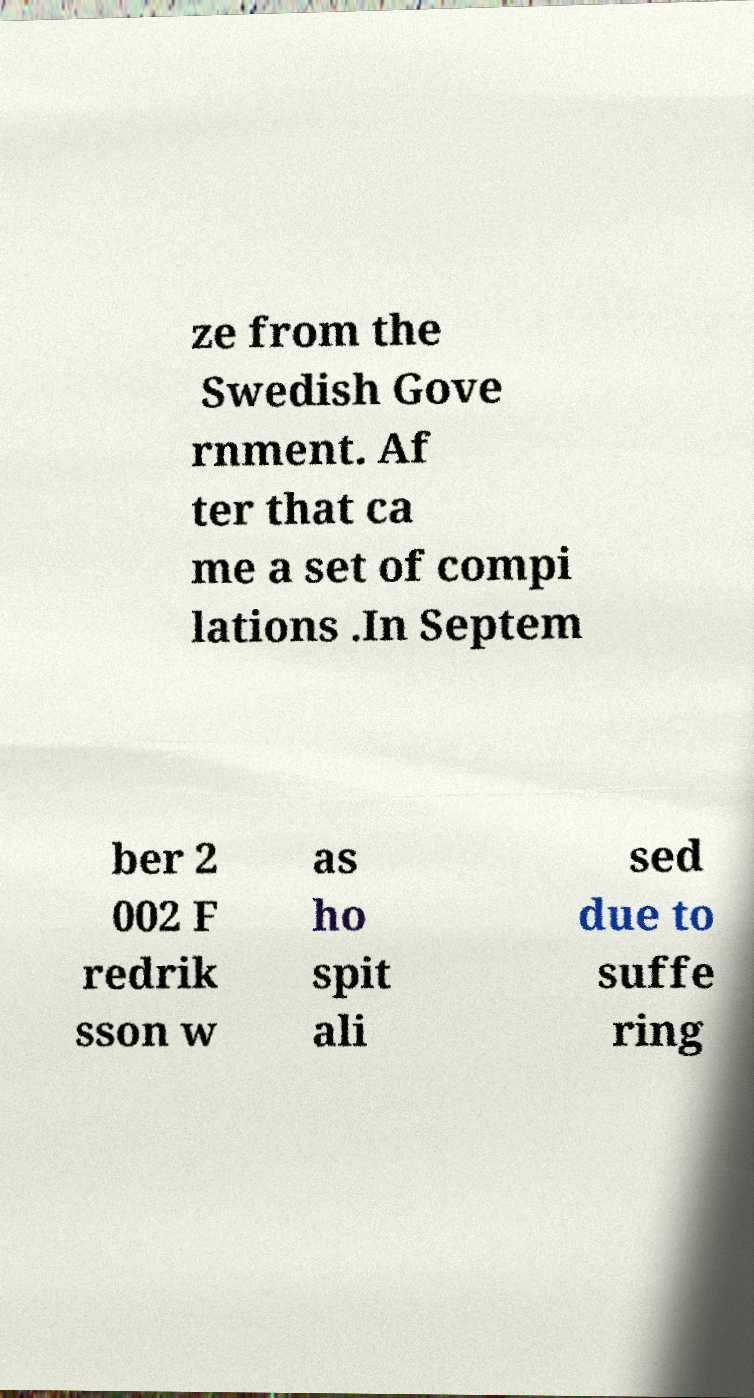Could you assist in decoding the text presented in this image and type it out clearly? ze from the Swedish Gove rnment. Af ter that ca me a set of compi lations .In Septem ber 2 002 F redrik sson w as ho spit ali sed due to suffe ring 